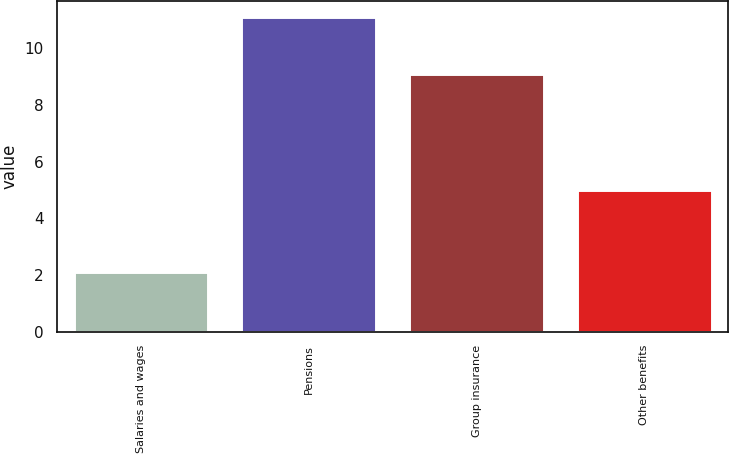Convert chart to OTSL. <chart><loc_0><loc_0><loc_500><loc_500><bar_chart><fcel>Salaries and wages<fcel>Pensions<fcel>Group insurance<fcel>Other benefits<nl><fcel>2.1<fcel>11.1<fcel>9.1<fcel>5<nl></chart> 